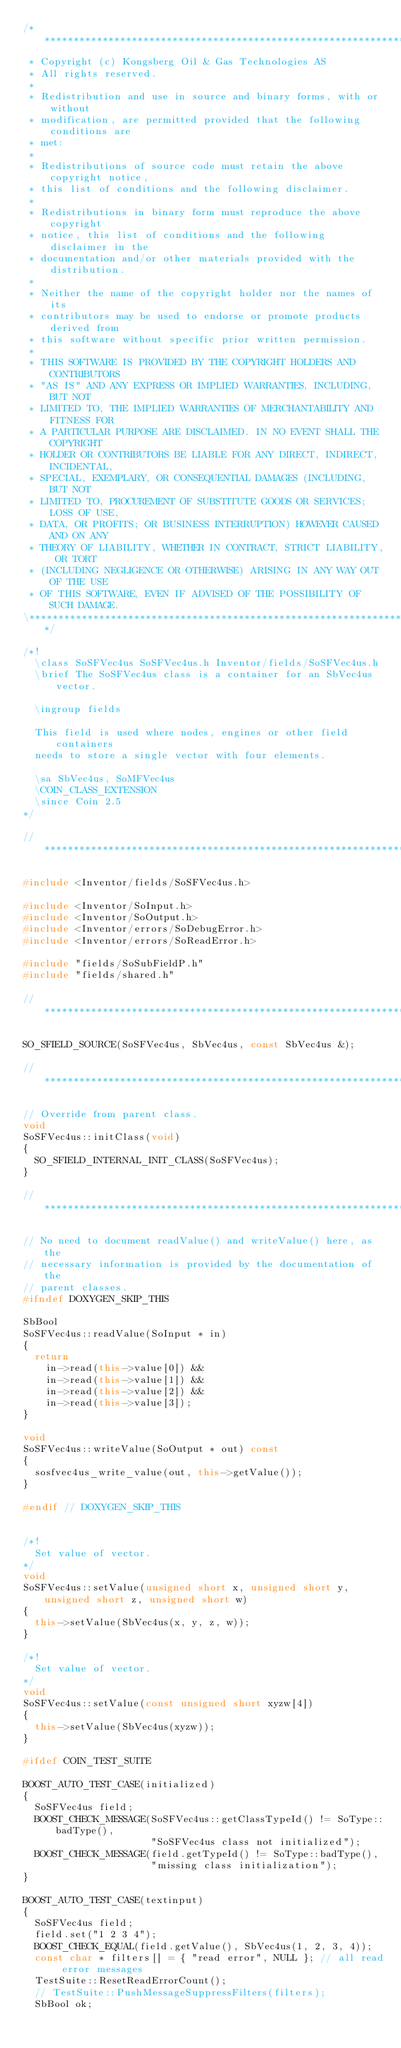<code> <loc_0><loc_0><loc_500><loc_500><_C++_>/**************************************************************************\
 * Copyright (c) Kongsberg Oil & Gas Technologies AS
 * All rights reserved.
 * 
 * Redistribution and use in source and binary forms, with or without
 * modification, are permitted provided that the following conditions are
 * met:
 * 
 * Redistributions of source code must retain the above copyright notice,
 * this list of conditions and the following disclaimer.
 * 
 * Redistributions in binary form must reproduce the above copyright
 * notice, this list of conditions and the following disclaimer in the
 * documentation and/or other materials provided with the distribution.
 * 
 * Neither the name of the copyright holder nor the names of its
 * contributors may be used to endorse or promote products derived from
 * this software without specific prior written permission.
 * 
 * THIS SOFTWARE IS PROVIDED BY THE COPYRIGHT HOLDERS AND CONTRIBUTORS
 * "AS IS" AND ANY EXPRESS OR IMPLIED WARRANTIES, INCLUDING, BUT NOT
 * LIMITED TO, THE IMPLIED WARRANTIES OF MERCHANTABILITY AND FITNESS FOR
 * A PARTICULAR PURPOSE ARE DISCLAIMED. IN NO EVENT SHALL THE COPYRIGHT
 * HOLDER OR CONTRIBUTORS BE LIABLE FOR ANY DIRECT, INDIRECT, INCIDENTAL,
 * SPECIAL, EXEMPLARY, OR CONSEQUENTIAL DAMAGES (INCLUDING, BUT NOT
 * LIMITED TO, PROCUREMENT OF SUBSTITUTE GOODS OR SERVICES; LOSS OF USE,
 * DATA, OR PROFITS; OR BUSINESS INTERRUPTION) HOWEVER CAUSED AND ON ANY
 * THEORY OF LIABILITY, WHETHER IN CONTRACT, STRICT LIABILITY, OR TORT
 * (INCLUDING NEGLIGENCE OR OTHERWISE) ARISING IN ANY WAY OUT OF THE USE
 * OF THIS SOFTWARE, EVEN IF ADVISED OF THE POSSIBILITY OF SUCH DAMAGE.
\**************************************************************************/

/*!
  \class SoSFVec4us SoSFVec4us.h Inventor/fields/SoSFVec4us.h
  \brief The SoSFVec4us class is a container for an SbVec4us vector.

  \ingroup fields

  This field is used where nodes, engines or other field containers
  needs to store a single vector with four elements.

  \sa SbVec4us, SoMFVec4us
  \COIN_CLASS_EXTENSION
  \since Coin 2.5
*/

// *************************************************************************

#include <Inventor/fields/SoSFVec4us.h>

#include <Inventor/SoInput.h>
#include <Inventor/SoOutput.h>
#include <Inventor/errors/SoDebugError.h>
#include <Inventor/errors/SoReadError.h>

#include "fields/SoSubFieldP.h"
#include "fields/shared.h"

// *************************************************************************

SO_SFIELD_SOURCE(SoSFVec4us, SbVec4us, const SbVec4us &);

// *************************************************************************

// Override from parent class.
void
SoSFVec4us::initClass(void)
{
  SO_SFIELD_INTERNAL_INIT_CLASS(SoSFVec4us);
}

// *************************************************************************

// No need to document readValue() and writeValue() here, as the
// necessary information is provided by the documentation of the
// parent classes.
#ifndef DOXYGEN_SKIP_THIS

SbBool
SoSFVec4us::readValue(SoInput * in)
{
  return
    in->read(this->value[0]) &&
    in->read(this->value[1]) &&
    in->read(this->value[2]) &&
    in->read(this->value[3]);
}

void
SoSFVec4us::writeValue(SoOutput * out) const
{
  sosfvec4us_write_value(out, this->getValue());
}

#endif // DOXYGEN_SKIP_THIS


/*!
  Set value of vector.
*/
void
SoSFVec4us::setValue(unsigned short x, unsigned short y, unsigned short z, unsigned short w)
{
  this->setValue(SbVec4us(x, y, z, w));
}

/*!
  Set value of vector.
*/
void
SoSFVec4us::setValue(const unsigned short xyzw[4])
{
  this->setValue(SbVec4us(xyzw));
}

#ifdef COIN_TEST_SUITE

BOOST_AUTO_TEST_CASE(initialized)
{
  SoSFVec4us field;
  BOOST_CHECK_MESSAGE(SoSFVec4us::getClassTypeId() != SoType::badType(),
                      "SoSFVec4us class not initialized");
  BOOST_CHECK_MESSAGE(field.getTypeId() != SoType::badType(),
                      "missing class initialization");
}

BOOST_AUTO_TEST_CASE(textinput)
{
  SoSFVec4us field;
  field.set("1 2 3 4");
  BOOST_CHECK_EQUAL(field.getValue(), SbVec4us(1, 2, 3, 4));
  const char * filters[] = { "read error", NULL }; // all read error messages
  TestSuite::ResetReadErrorCount();
  // TestSuite::PushMessageSuppressFilters(filters);
  SbBool ok;</code> 